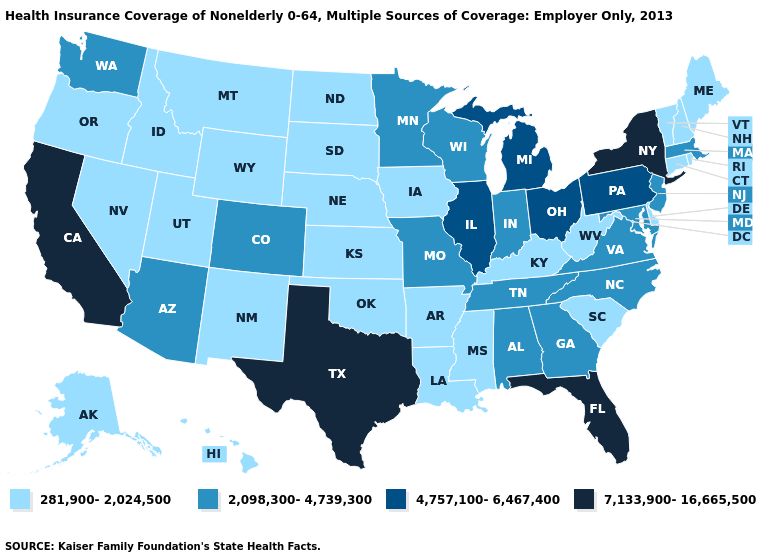Does New Hampshire have a lower value than Georgia?
Answer briefly. Yes. What is the highest value in the Northeast ?
Quick response, please. 7,133,900-16,665,500. Name the states that have a value in the range 4,757,100-6,467,400?
Keep it brief. Illinois, Michigan, Ohio, Pennsylvania. How many symbols are there in the legend?
Be succinct. 4. Name the states that have a value in the range 7,133,900-16,665,500?
Keep it brief. California, Florida, New York, Texas. Which states have the lowest value in the USA?
Give a very brief answer. Alaska, Arkansas, Connecticut, Delaware, Hawaii, Idaho, Iowa, Kansas, Kentucky, Louisiana, Maine, Mississippi, Montana, Nebraska, Nevada, New Hampshire, New Mexico, North Dakota, Oklahoma, Oregon, Rhode Island, South Carolina, South Dakota, Utah, Vermont, West Virginia, Wyoming. Name the states that have a value in the range 2,098,300-4,739,300?
Give a very brief answer. Alabama, Arizona, Colorado, Georgia, Indiana, Maryland, Massachusetts, Minnesota, Missouri, New Jersey, North Carolina, Tennessee, Virginia, Washington, Wisconsin. Is the legend a continuous bar?
Quick response, please. No. Among the states that border Rhode Island , which have the lowest value?
Write a very short answer. Connecticut. Among the states that border New York , which have the lowest value?
Keep it brief. Connecticut, Vermont. What is the lowest value in the MidWest?
Give a very brief answer. 281,900-2,024,500. What is the value of South Carolina?
Short answer required. 281,900-2,024,500. What is the highest value in the South ?
Answer briefly. 7,133,900-16,665,500. Does Ohio have the highest value in the MidWest?
Short answer required. Yes. Which states have the lowest value in the MidWest?
Be succinct. Iowa, Kansas, Nebraska, North Dakota, South Dakota. 